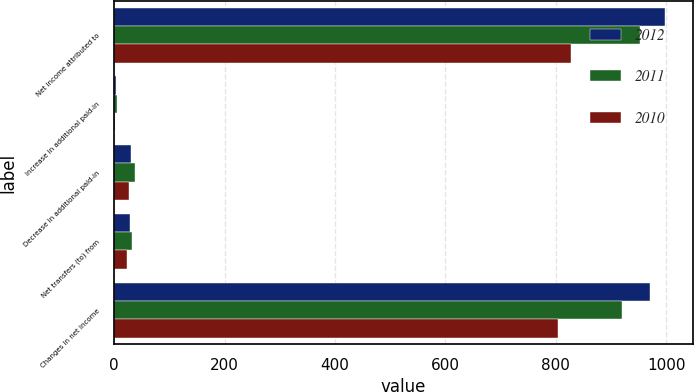Convert chart. <chart><loc_0><loc_0><loc_500><loc_500><stacked_bar_chart><ecel><fcel>Net income attributed to<fcel>Increase in additional paid-in<fcel>Decrease in additional paid-in<fcel>Net transfers (to) from<fcel>Changes in net income<nl><fcel>2012<fcel>998.3<fcel>2.6<fcel>30.7<fcel>28.1<fcel>970.2<nl><fcel>2011<fcel>952.6<fcel>4.8<fcel>37.6<fcel>32.8<fcel>919.8<nl><fcel>2010<fcel>827.7<fcel>2.2<fcel>26<fcel>23.8<fcel>803.9<nl></chart> 